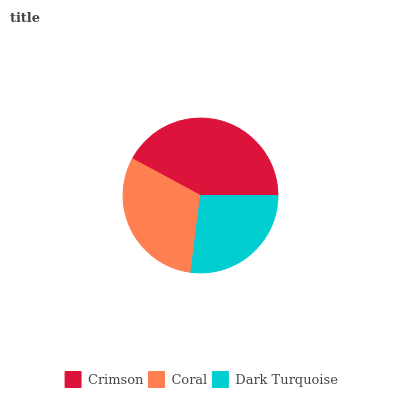Is Dark Turquoise the minimum?
Answer yes or no. Yes. Is Crimson the maximum?
Answer yes or no. Yes. Is Coral the minimum?
Answer yes or no. No. Is Coral the maximum?
Answer yes or no. No. Is Crimson greater than Coral?
Answer yes or no. Yes. Is Coral less than Crimson?
Answer yes or no. Yes. Is Coral greater than Crimson?
Answer yes or no. No. Is Crimson less than Coral?
Answer yes or no. No. Is Coral the high median?
Answer yes or no. Yes. Is Coral the low median?
Answer yes or no. Yes. Is Dark Turquoise the high median?
Answer yes or no. No. Is Dark Turquoise the low median?
Answer yes or no. No. 